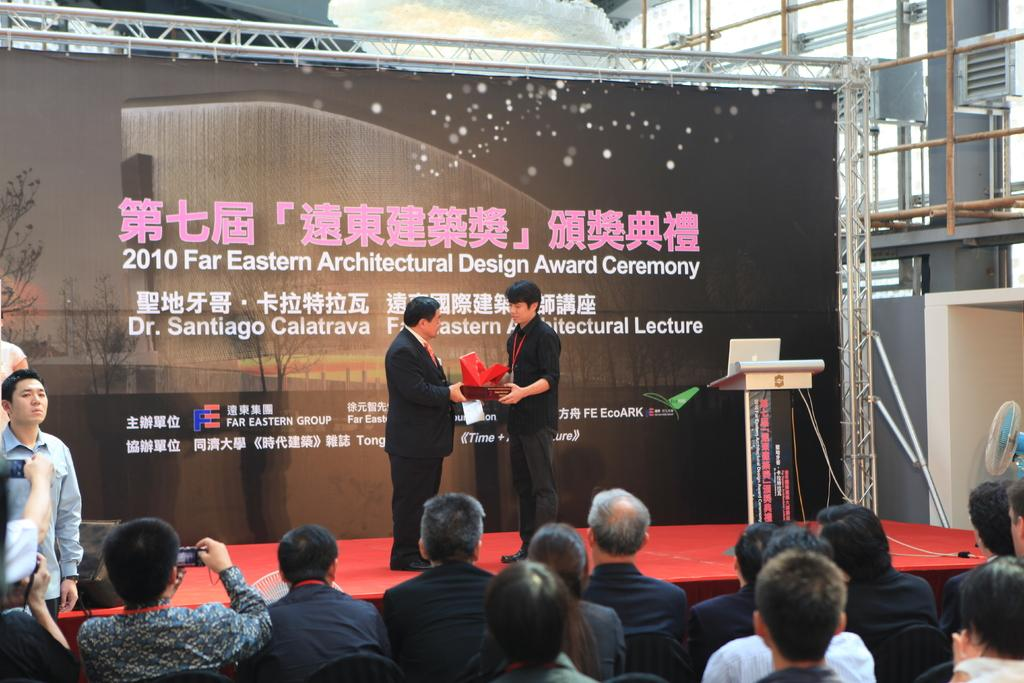How many people are in the image? There are people in the image, but the exact number is not specified. What are the two persons on the stage doing? The two persons on the stage are standing. What can be seen in the background of the image? There is text on a wall in the background of the image. How many dogs are present in the image? There is no mention of dogs in the image, so we cannot determine their presence or number. 